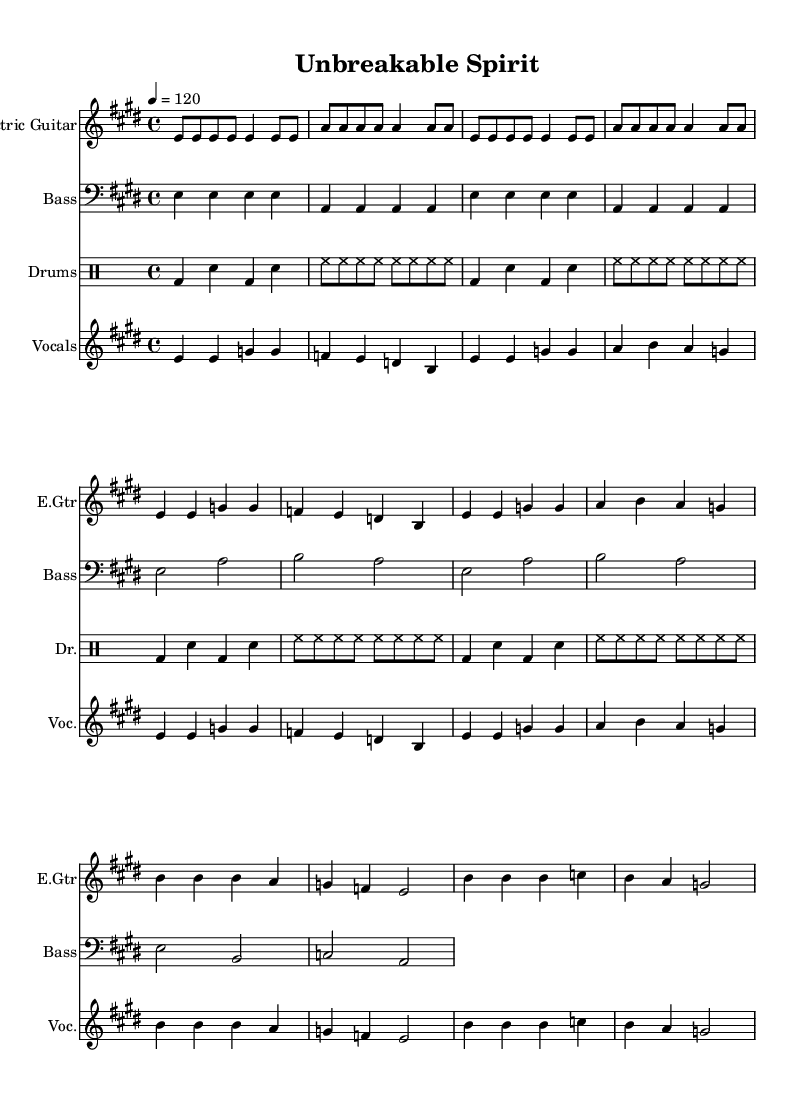What is the key signature of this music? The key signature is indicated by the sharps or flats at the beginning of the staff. In this case, there is four sharps represented, which identifies it as E major.
Answer: E major What is the time signature of this music? The time signature is located immediately after the key signature and is represented as a fraction. In this case, it is 4 over 4, indicating four beats per measure.
Answer: 4/4 What is the tempo marking for this piece? The tempo marking is indicated in beats per minute at the beginning. Here, it states "4 = 120," meaning it should be played at 120 beats per minute.
Answer: 120 How many bars are in the first section of the guitar part? The first section of the guitar part contains four measures before the pattern repeats, allowing us to count the distinct bars.
Answer: 4 What instruments are featured in this score? The instruments are listed at the beginning of each staff. They include Electric Guitar, Bass, Drums, and Vocals.
Answer: Electric Guitar, Bass, Drums, Vocals What lyrics correspond to the first line of the vocal part? The first line of the vocal part can be extracted directly from the lyrics under the vocal staff. The first line reads "In the face of adversity, we stand tall."
Answer: In the face of adversity, we stand tall Which section of the song emphasizes the theme of perseverance? The theme of perseverance can be identified by analyzing the lyrics, especially where the message is clearly stated: "Never give up, give it all we've got."
Answer: Never give up 